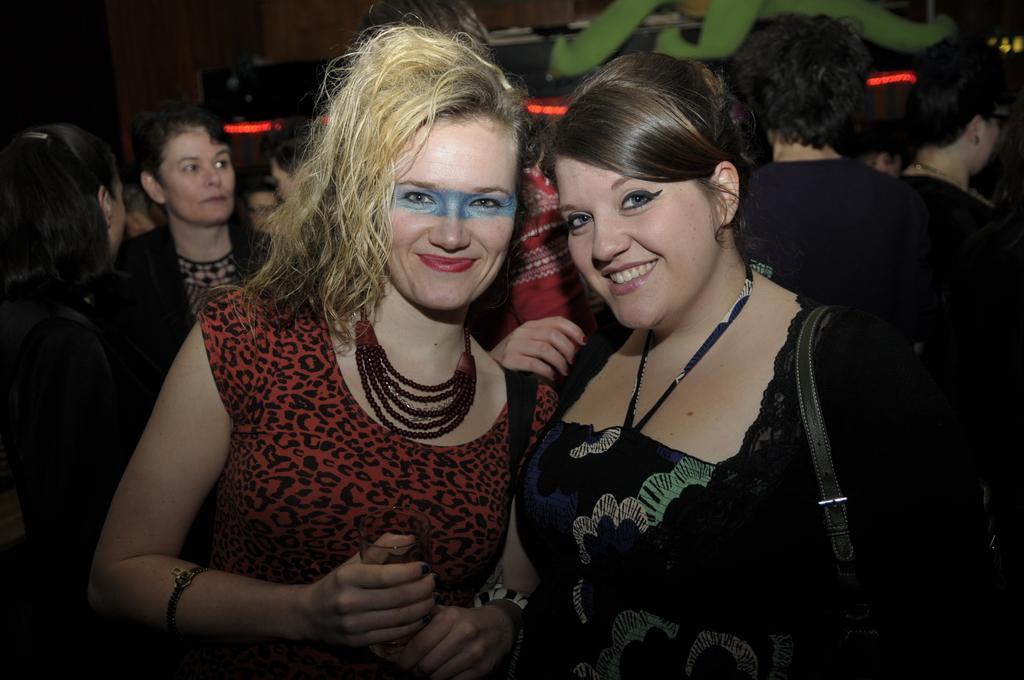How would you summarize this image in a sentence or two? In this image, we can see a group of people wearing clothes. There is a person on the right side of the image, wearing a bag. 